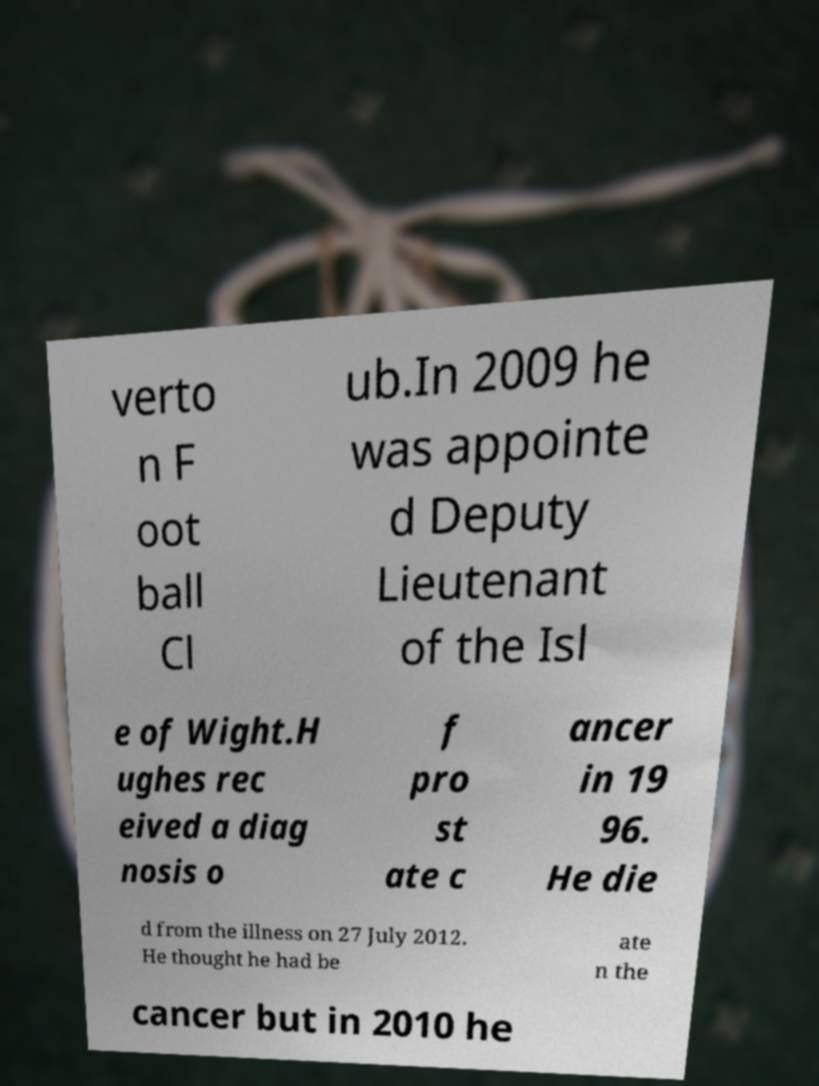Can you accurately transcribe the text from the provided image for me? verto n F oot ball Cl ub.In 2009 he was appointe d Deputy Lieutenant of the Isl e of Wight.H ughes rec eived a diag nosis o f pro st ate c ancer in 19 96. He die d from the illness on 27 July 2012. He thought he had be ate n the cancer but in 2010 he 